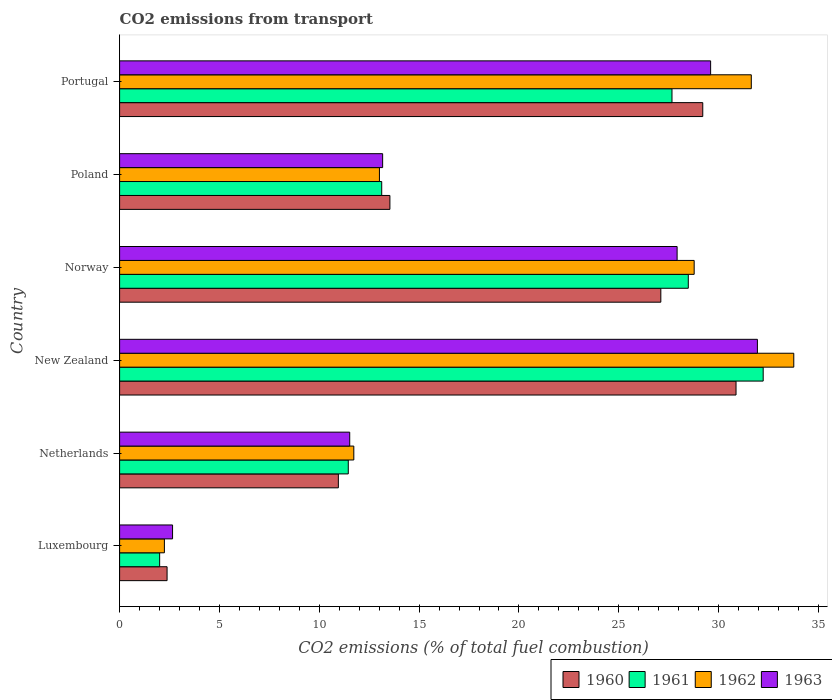How many different coloured bars are there?
Your answer should be compact. 4. Are the number of bars on each tick of the Y-axis equal?
Your answer should be compact. Yes. What is the total CO2 emitted in 1960 in Poland?
Offer a terse response. 13.54. Across all countries, what is the maximum total CO2 emitted in 1961?
Your response must be concise. 32.23. Across all countries, what is the minimum total CO2 emitted in 1961?
Give a very brief answer. 2.01. In which country was the total CO2 emitted in 1960 maximum?
Your response must be concise. New Zealand. In which country was the total CO2 emitted in 1960 minimum?
Make the answer very short. Luxembourg. What is the total total CO2 emitted in 1962 in the graph?
Your response must be concise. 121.17. What is the difference between the total CO2 emitted in 1962 in Netherlands and that in Norway?
Your response must be concise. -17.05. What is the difference between the total CO2 emitted in 1962 in Poland and the total CO2 emitted in 1961 in Luxembourg?
Your answer should be compact. 11.01. What is the average total CO2 emitted in 1960 per country?
Make the answer very short. 19.01. What is the difference between the total CO2 emitted in 1962 and total CO2 emitted in 1961 in Portugal?
Your answer should be very brief. 3.97. In how many countries, is the total CO2 emitted in 1961 greater than 25 ?
Provide a succinct answer. 3. What is the ratio of the total CO2 emitted in 1963 in New Zealand to that in Portugal?
Your answer should be very brief. 1.08. Is the total CO2 emitted in 1962 in New Zealand less than that in Norway?
Give a very brief answer. No. What is the difference between the highest and the second highest total CO2 emitted in 1961?
Keep it short and to the point. 3.75. What is the difference between the highest and the lowest total CO2 emitted in 1962?
Keep it short and to the point. 31.52. Is the sum of the total CO2 emitted in 1960 in Netherlands and Poland greater than the maximum total CO2 emitted in 1961 across all countries?
Provide a short and direct response. No. What does the 1st bar from the top in Poland represents?
Provide a succinct answer. 1963. How many countries are there in the graph?
Provide a succinct answer. 6. What is the difference between two consecutive major ticks on the X-axis?
Give a very brief answer. 5. Are the values on the major ticks of X-axis written in scientific E-notation?
Your answer should be very brief. No. Does the graph contain any zero values?
Provide a short and direct response. No. How many legend labels are there?
Give a very brief answer. 4. What is the title of the graph?
Provide a succinct answer. CO2 emissions from transport. Does "1981" appear as one of the legend labels in the graph?
Offer a very short reply. No. What is the label or title of the X-axis?
Provide a short and direct response. CO2 emissions (% of total fuel combustion). What is the label or title of the Y-axis?
Ensure brevity in your answer.  Country. What is the CO2 emissions (% of total fuel combustion) of 1960 in Luxembourg?
Your answer should be very brief. 2.38. What is the CO2 emissions (% of total fuel combustion) of 1961 in Luxembourg?
Give a very brief answer. 2.01. What is the CO2 emissions (% of total fuel combustion) in 1962 in Luxembourg?
Your answer should be very brief. 2.24. What is the CO2 emissions (% of total fuel combustion) of 1963 in Luxembourg?
Your response must be concise. 2.65. What is the CO2 emissions (% of total fuel combustion) in 1960 in Netherlands?
Keep it short and to the point. 10.96. What is the CO2 emissions (% of total fuel combustion) in 1961 in Netherlands?
Your answer should be compact. 11.45. What is the CO2 emissions (% of total fuel combustion) in 1962 in Netherlands?
Ensure brevity in your answer.  11.73. What is the CO2 emissions (% of total fuel combustion) of 1963 in Netherlands?
Give a very brief answer. 11.53. What is the CO2 emissions (% of total fuel combustion) in 1960 in New Zealand?
Ensure brevity in your answer.  30.87. What is the CO2 emissions (% of total fuel combustion) of 1961 in New Zealand?
Offer a very short reply. 32.23. What is the CO2 emissions (% of total fuel combustion) of 1962 in New Zealand?
Give a very brief answer. 33.77. What is the CO2 emissions (% of total fuel combustion) of 1963 in New Zealand?
Provide a short and direct response. 31.94. What is the CO2 emissions (% of total fuel combustion) of 1960 in Norway?
Your answer should be very brief. 27.11. What is the CO2 emissions (% of total fuel combustion) in 1961 in Norway?
Offer a very short reply. 28.48. What is the CO2 emissions (% of total fuel combustion) of 1962 in Norway?
Offer a very short reply. 28.78. What is the CO2 emissions (% of total fuel combustion) of 1963 in Norway?
Keep it short and to the point. 27.92. What is the CO2 emissions (% of total fuel combustion) in 1960 in Poland?
Provide a succinct answer. 13.54. What is the CO2 emissions (% of total fuel combustion) in 1961 in Poland?
Ensure brevity in your answer.  13.13. What is the CO2 emissions (% of total fuel combustion) of 1962 in Poland?
Provide a short and direct response. 13.01. What is the CO2 emissions (% of total fuel combustion) in 1963 in Poland?
Offer a very short reply. 13.17. What is the CO2 emissions (% of total fuel combustion) of 1960 in Portugal?
Your response must be concise. 29.21. What is the CO2 emissions (% of total fuel combustion) of 1961 in Portugal?
Offer a very short reply. 27.67. What is the CO2 emissions (% of total fuel combustion) in 1962 in Portugal?
Offer a terse response. 31.64. What is the CO2 emissions (% of total fuel combustion) in 1963 in Portugal?
Provide a succinct answer. 29.6. Across all countries, what is the maximum CO2 emissions (% of total fuel combustion) of 1960?
Provide a succinct answer. 30.87. Across all countries, what is the maximum CO2 emissions (% of total fuel combustion) in 1961?
Your answer should be very brief. 32.23. Across all countries, what is the maximum CO2 emissions (% of total fuel combustion) in 1962?
Offer a terse response. 33.77. Across all countries, what is the maximum CO2 emissions (% of total fuel combustion) in 1963?
Provide a succinct answer. 31.94. Across all countries, what is the minimum CO2 emissions (% of total fuel combustion) in 1960?
Keep it short and to the point. 2.38. Across all countries, what is the minimum CO2 emissions (% of total fuel combustion) in 1961?
Make the answer very short. 2.01. Across all countries, what is the minimum CO2 emissions (% of total fuel combustion) in 1962?
Make the answer very short. 2.24. Across all countries, what is the minimum CO2 emissions (% of total fuel combustion) in 1963?
Provide a short and direct response. 2.65. What is the total CO2 emissions (% of total fuel combustion) in 1960 in the graph?
Provide a succinct answer. 114.06. What is the total CO2 emissions (% of total fuel combustion) in 1961 in the graph?
Your response must be concise. 114.97. What is the total CO2 emissions (% of total fuel combustion) in 1962 in the graph?
Provide a short and direct response. 121.17. What is the total CO2 emissions (% of total fuel combustion) of 1963 in the graph?
Your answer should be very brief. 116.82. What is the difference between the CO2 emissions (% of total fuel combustion) of 1960 in Luxembourg and that in Netherlands?
Provide a short and direct response. -8.58. What is the difference between the CO2 emissions (% of total fuel combustion) of 1961 in Luxembourg and that in Netherlands?
Give a very brief answer. -9.45. What is the difference between the CO2 emissions (% of total fuel combustion) of 1962 in Luxembourg and that in Netherlands?
Make the answer very short. -9.49. What is the difference between the CO2 emissions (% of total fuel combustion) in 1963 in Luxembourg and that in Netherlands?
Offer a terse response. -8.87. What is the difference between the CO2 emissions (% of total fuel combustion) in 1960 in Luxembourg and that in New Zealand?
Keep it short and to the point. -28.5. What is the difference between the CO2 emissions (% of total fuel combustion) of 1961 in Luxembourg and that in New Zealand?
Your answer should be compact. -30.23. What is the difference between the CO2 emissions (% of total fuel combustion) in 1962 in Luxembourg and that in New Zealand?
Offer a terse response. -31.52. What is the difference between the CO2 emissions (% of total fuel combustion) of 1963 in Luxembourg and that in New Zealand?
Offer a very short reply. -29.29. What is the difference between the CO2 emissions (% of total fuel combustion) in 1960 in Luxembourg and that in Norway?
Your response must be concise. -24.73. What is the difference between the CO2 emissions (% of total fuel combustion) of 1961 in Luxembourg and that in Norway?
Your answer should be very brief. -26.48. What is the difference between the CO2 emissions (% of total fuel combustion) in 1962 in Luxembourg and that in Norway?
Provide a short and direct response. -26.53. What is the difference between the CO2 emissions (% of total fuel combustion) of 1963 in Luxembourg and that in Norway?
Your response must be concise. -25.27. What is the difference between the CO2 emissions (% of total fuel combustion) in 1960 in Luxembourg and that in Poland?
Keep it short and to the point. -11.16. What is the difference between the CO2 emissions (% of total fuel combustion) in 1961 in Luxembourg and that in Poland?
Provide a succinct answer. -11.12. What is the difference between the CO2 emissions (% of total fuel combustion) in 1962 in Luxembourg and that in Poland?
Keep it short and to the point. -10.77. What is the difference between the CO2 emissions (% of total fuel combustion) of 1963 in Luxembourg and that in Poland?
Make the answer very short. -10.52. What is the difference between the CO2 emissions (% of total fuel combustion) of 1960 in Luxembourg and that in Portugal?
Your response must be concise. -26.83. What is the difference between the CO2 emissions (% of total fuel combustion) in 1961 in Luxembourg and that in Portugal?
Ensure brevity in your answer.  -25.66. What is the difference between the CO2 emissions (% of total fuel combustion) in 1962 in Luxembourg and that in Portugal?
Offer a terse response. -29.4. What is the difference between the CO2 emissions (% of total fuel combustion) of 1963 in Luxembourg and that in Portugal?
Offer a terse response. -26.95. What is the difference between the CO2 emissions (% of total fuel combustion) in 1960 in Netherlands and that in New Zealand?
Give a very brief answer. -19.92. What is the difference between the CO2 emissions (% of total fuel combustion) of 1961 in Netherlands and that in New Zealand?
Your response must be concise. -20.78. What is the difference between the CO2 emissions (% of total fuel combustion) of 1962 in Netherlands and that in New Zealand?
Your answer should be very brief. -22.04. What is the difference between the CO2 emissions (% of total fuel combustion) of 1963 in Netherlands and that in New Zealand?
Your answer should be very brief. -20.42. What is the difference between the CO2 emissions (% of total fuel combustion) of 1960 in Netherlands and that in Norway?
Provide a succinct answer. -16.15. What is the difference between the CO2 emissions (% of total fuel combustion) in 1961 in Netherlands and that in Norway?
Your response must be concise. -17.03. What is the difference between the CO2 emissions (% of total fuel combustion) in 1962 in Netherlands and that in Norway?
Give a very brief answer. -17.05. What is the difference between the CO2 emissions (% of total fuel combustion) in 1963 in Netherlands and that in Norway?
Make the answer very short. -16.4. What is the difference between the CO2 emissions (% of total fuel combustion) of 1960 in Netherlands and that in Poland?
Offer a very short reply. -2.58. What is the difference between the CO2 emissions (% of total fuel combustion) of 1961 in Netherlands and that in Poland?
Offer a very short reply. -1.67. What is the difference between the CO2 emissions (% of total fuel combustion) in 1962 in Netherlands and that in Poland?
Provide a succinct answer. -1.28. What is the difference between the CO2 emissions (% of total fuel combustion) in 1963 in Netherlands and that in Poland?
Give a very brief answer. -1.65. What is the difference between the CO2 emissions (% of total fuel combustion) in 1960 in Netherlands and that in Portugal?
Ensure brevity in your answer.  -18.25. What is the difference between the CO2 emissions (% of total fuel combustion) in 1961 in Netherlands and that in Portugal?
Make the answer very short. -16.21. What is the difference between the CO2 emissions (% of total fuel combustion) in 1962 in Netherlands and that in Portugal?
Provide a succinct answer. -19.91. What is the difference between the CO2 emissions (% of total fuel combustion) in 1963 in Netherlands and that in Portugal?
Ensure brevity in your answer.  -18.08. What is the difference between the CO2 emissions (% of total fuel combustion) in 1960 in New Zealand and that in Norway?
Provide a short and direct response. 3.77. What is the difference between the CO2 emissions (% of total fuel combustion) in 1961 in New Zealand and that in Norway?
Your answer should be compact. 3.75. What is the difference between the CO2 emissions (% of total fuel combustion) of 1962 in New Zealand and that in Norway?
Ensure brevity in your answer.  4.99. What is the difference between the CO2 emissions (% of total fuel combustion) of 1963 in New Zealand and that in Norway?
Provide a short and direct response. 4.02. What is the difference between the CO2 emissions (% of total fuel combustion) in 1960 in New Zealand and that in Poland?
Your answer should be very brief. 17.34. What is the difference between the CO2 emissions (% of total fuel combustion) in 1961 in New Zealand and that in Poland?
Provide a succinct answer. 19.11. What is the difference between the CO2 emissions (% of total fuel combustion) of 1962 in New Zealand and that in Poland?
Give a very brief answer. 20.75. What is the difference between the CO2 emissions (% of total fuel combustion) in 1963 in New Zealand and that in Poland?
Your answer should be compact. 18.77. What is the difference between the CO2 emissions (% of total fuel combustion) in 1960 in New Zealand and that in Portugal?
Keep it short and to the point. 1.67. What is the difference between the CO2 emissions (% of total fuel combustion) of 1961 in New Zealand and that in Portugal?
Provide a succinct answer. 4.57. What is the difference between the CO2 emissions (% of total fuel combustion) in 1962 in New Zealand and that in Portugal?
Keep it short and to the point. 2.13. What is the difference between the CO2 emissions (% of total fuel combustion) of 1963 in New Zealand and that in Portugal?
Your answer should be very brief. 2.34. What is the difference between the CO2 emissions (% of total fuel combustion) in 1960 in Norway and that in Poland?
Make the answer very short. 13.57. What is the difference between the CO2 emissions (% of total fuel combustion) in 1961 in Norway and that in Poland?
Offer a terse response. 15.36. What is the difference between the CO2 emissions (% of total fuel combustion) of 1962 in Norway and that in Poland?
Keep it short and to the point. 15.76. What is the difference between the CO2 emissions (% of total fuel combustion) in 1963 in Norway and that in Poland?
Provide a short and direct response. 14.75. What is the difference between the CO2 emissions (% of total fuel combustion) in 1960 in Norway and that in Portugal?
Make the answer very short. -2.1. What is the difference between the CO2 emissions (% of total fuel combustion) in 1961 in Norway and that in Portugal?
Offer a terse response. 0.82. What is the difference between the CO2 emissions (% of total fuel combustion) of 1962 in Norway and that in Portugal?
Make the answer very short. -2.86. What is the difference between the CO2 emissions (% of total fuel combustion) in 1963 in Norway and that in Portugal?
Your response must be concise. -1.68. What is the difference between the CO2 emissions (% of total fuel combustion) of 1960 in Poland and that in Portugal?
Give a very brief answer. -15.67. What is the difference between the CO2 emissions (% of total fuel combustion) of 1961 in Poland and that in Portugal?
Provide a short and direct response. -14.54. What is the difference between the CO2 emissions (% of total fuel combustion) in 1962 in Poland and that in Portugal?
Make the answer very short. -18.62. What is the difference between the CO2 emissions (% of total fuel combustion) of 1963 in Poland and that in Portugal?
Provide a short and direct response. -16.43. What is the difference between the CO2 emissions (% of total fuel combustion) in 1960 in Luxembourg and the CO2 emissions (% of total fuel combustion) in 1961 in Netherlands?
Ensure brevity in your answer.  -9.08. What is the difference between the CO2 emissions (% of total fuel combustion) in 1960 in Luxembourg and the CO2 emissions (% of total fuel combustion) in 1962 in Netherlands?
Offer a very short reply. -9.35. What is the difference between the CO2 emissions (% of total fuel combustion) in 1960 in Luxembourg and the CO2 emissions (% of total fuel combustion) in 1963 in Netherlands?
Your answer should be compact. -9.15. What is the difference between the CO2 emissions (% of total fuel combustion) of 1961 in Luxembourg and the CO2 emissions (% of total fuel combustion) of 1962 in Netherlands?
Keep it short and to the point. -9.72. What is the difference between the CO2 emissions (% of total fuel combustion) in 1961 in Luxembourg and the CO2 emissions (% of total fuel combustion) in 1963 in Netherlands?
Give a very brief answer. -9.52. What is the difference between the CO2 emissions (% of total fuel combustion) in 1962 in Luxembourg and the CO2 emissions (% of total fuel combustion) in 1963 in Netherlands?
Your response must be concise. -9.28. What is the difference between the CO2 emissions (% of total fuel combustion) in 1960 in Luxembourg and the CO2 emissions (% of total fuel combustion) in 1961 in New Zealand?
Provide a short and direct response. -29.86. What is the difference between the CO2 emissions (% of total fuel combustion) of 1960 in Luxembourg and the CO2 emissions (% of total fuel combustion) of 1962 in New Zealand?
Make the answer very short. -31.39. What is the difference between the CO2 emissions (% of total fuel combustion) of 1960 in Luxembourg and the CO2 emissions (% of total fuel combustion) of 1963 in New Zealand?
Offer a very short reply. -29.57. What is the difference between the CO2 emissions (% of total fuel combustion) in 1961 in Luxembourg and the CO2 emissions (% of total fuel combustion) in 1962 in New Zealand?
Offer a very short reply. -31.76. What is the difference between the CO2 emissions (% of total fuel combustion) of 1961 in Luxembourg and the CO2 emissions (% of total fuel combustion) of 1963 in New Zealand?
Your answer should be compact. -29.94. What is the difference between the CO2 emissions (% of total fuel combustion) of 1962 in Luxembourg and the CO2 emissions (% of total fuel combustion) of 1963 in New Zealand?
Provide a succinct answer. -29.7. What is the difference between the CO2 emissions (% of total fuel combustion) in 1960 in Luxembourg and the CO2 emissions (% of total fuel combustion) in 1961 in Norway?
Make the answer very short. -26.1. What is the difference between the CO2 emissions (% of total fuel combustion) in 1960 in Luxembourg and the CO2 emissions (% of total fuel combustion) in 1962 in Norway?
Make the answer very short. -26.4. What is the difference between the CO2 emissions (% of total fuel combustion) of 1960 in Luxembourg and the CO2 emissions (% of total fuel combustion) of 1963 in Norway?
Ensure brevity in your answer.  -25.54. What is the difference between the CO2 emissions (% of total fuel combustion) of 1961 in Luxembourg and the CO2 emissions (% of total fuel combustion) of 1962 in Norway?
Your response must be concise. -26.77. What is the difference between the CO2 emissions (% of total fuel combustion) in 1961 in Luxembourg and the CO2 emissions (% of total fuel combustion) in 1963 in Norway?
Keep it short and to the point. -25.92. What is the difference between the CO2 emissions (% of total fuel combustion) in 1962 in Luxembourg and the CO2 emissions (% of total fuel combustion) in 1963 in Norway?
Make the answer very short. -25.68. What is the difference between the CO2 emissions (% of total fuel combustion) in 1960 in Luxembourg and the CO2 emissions (% of total fuel combustion) in 1961 in Poland?
Offer a terse response. -10.75. What is the difference between the CO2 emissions (% of total fuel combustion) of 1960 in Luxembourg and the CO2 emissions (% of total fuel combustion) of 1962 in Poland?
Keep it short and to the point. -10.64. What is the difference between the CO2 emissions (% of total fuel combustion) of 1960 in Luxembourg and the CO2 emissions (% of total fuel combustion) of 1963 in Poland?
Your response must be concise. -10.8. What is the difference between the CO2 emissions (% of total fuel combustion) in 1961 in Luxembourg and the CO2 emissions (% of total fuel combustion) in 1962 in Poland?
Your answer should be very brief. -11.01. What is the difference between the CO2 emissions (% of total fuel combustion) of 1961 in Luxembourg and the CO2 emissions (% of total fuel combustion) of 1963 in Poland?
Offer a terse response. -11.17. What is the difference between the CO2 emissions (% of total fuel combustion) of 1962 in Luxembourg and the CO2 emissions (% of total fuel combustion) of 1963 in Poland?
Provide a succinct answer. -10.93. What is the difference between the CO2 emissions (% of total fuel combustion) of 1960 in Luxembourg and the CO2 emissions (% of total fuel combustion) of 1961 in Portugal?
Offer a terse response. -25.29. What is the difference between the CO2 emissions (% of total fuel combustion) of 1960 in Luxembourg and the CO2 emissions (% of total fuel combustion) of 1962 in Portugal?
Your response must be concise. -29.26. What is the difference between the CO2 emissions (% of total fuel combustion) in 1960 in Luxembourg and the CO2 emissions (% of total fuel combustion) in 1963 in Portugal?
Your answer should be very brief. -27.22. What is the difference between the CO2 emissions (% of total fuel combustion) of 1961 in Luxembourg and the CO2 emissions (% of total fuel combustion) of 1962 in Portugal?
Make the answer very short. -29.63. What is the difference between the CO2 emissions (% of total fuel combustion) of 1961 in Luxembourg and the CO2 emissions (% of total fuel combustion) of 1963 in Portugal?
Keep it short and to the point. -27.6. What is the difference between the CO2 emissions (% of total fuel combustion) of 1962 in Luxembourg and the CO2 emissions (% of total fuel combustion) of 1963 in Portugal?
Provide a short and direct response. -27.36. What is the difference between the CO2 emissions (% of total fuel combustion) in 1960 in Netherlands and the CO2 emissions (% of total fuel combustion) in 1961 in New Zealand?
Ensure brevity in your answer.  -21.28. What is the difference between the CO2 emissions (% of total fuel combustion) in 1960 in Netherlands and the CO2 emissions (% of total fuel combustion) in 1962 in New Zealand?
Provide a short and direct response. -22.81. What is the difference between the CO2 emissions (% of total fuel combustion) of 1960 in Netherlands and the CO2 emissions (% of total fuel combustion) of 1963 in New Zealand?
Provide a short and direct response. -20.99. What is the difference between the CO2 emissions (% of total fuel combustion) in 1961 in Netherlands and the CO2 emissions (% of total fuel combustion) in 1962 in New Zealand?
Provide a short and direct response. -22.31. What is the difference between the CO2 emissions (% of total fuel combustion) in 1961 in Netherlands and the CO2 emissions (% of total fuel combustion) in 1963 in New Zealand?
Make the answer very short. -20.49. What is the difference between the CO2 emissions (% of total fuel combustion) of 1962 in Netherlands and the CO2 emissions (% of total fuel combustion) of 1963 in New Zealand?
Your response must be concise. -20.21. What is the difference between the CO2 emissions (% of total fuel combustion) in 1960 in Netherlands and the CO2 emissions (% of total fuel combustion) in 1961 in Norway?
Provide a short and direct response. -17.53. What is the difference between the CO2 emissions (% of total fuel combustion) of 1960 in Netherlands and the CO2 emissions (% of total fuel combustion) of 1962 in Norway?
Ensure brevity in your answer.  -17.82. What is the difference between the CO2 emissions (% of total fuel combustion) in 1960 in Netherlands and the CO2 emissions (% of total fuel combustion) in 1963 in Norway?
Your answer should be very brief. -16.97. What is the difference between the CO2 emissions (% of total fuel combustion) in 1961 in Netherlands and the CO2 emissions (% of total fuel combustion) in 1962 in Norway?
Your answer should be compact. -17.32. What is the difference between the CO2 emissions (% of total fuel combustion) in 1961 in Netherlands and the CO2 emissions (% of total fuel combustion) in 1963 in Norway?
Make the answer very short. -16.47. What is the difference between the CO2 emissions (% of total fuel combustion) of 1962 in Netherlands and the CO2 emissions (% of total fuel combustion) of 1963 in Norway?
Offer a very short reply. -16.19. What is the difference between the CO2 emissions (% of total fuel combustion) of 1960 in Netherlands and the CO2 emissions (% of total fuel combustion) of 1961 in Poland?
Your answer should be compact. -2.17. What is the difference between the CO2 emissions (% of total fuel combustion) in 1960 in Netherlands and the CO2 emissions (% of total fuel combustion) in 1962 in Poland?
Give a very brief answer. -2.06. What is the difference between the CO2 emissions (% of total fuel combustion) in 1960 in Netherlands and the CO2 emissions (% of total fuel combustion) in 1963 in Poland?
Make the answer very short. -2.22. What is the difference between the CO2 emissions (% of total fuel combustion) in 1961 in Netherlands and the CO2 emissions (% of total fuel combustion) in 1962 in Poland?
Your response must be concise. -1.56. What is the difference between the CO2 emissions (% of total fuel combustion) in 1961 in Netherlands and the CO2 emissions (% of total fuel combustion) in 1963 in Poland?
Provide a succinct answer. -1.72. What is the difference between the CO2 emissions (% of total fuel combustion) in 1962 in Netherlands and the CO2 emissions (% of total fuel combustion) in 1963 in Poland?
Give a very brief answer. -1.44. What is the difference between the CO2 emissions (% of total fuel combustion) in 1960 in Netherlands and the CO2 emissions (% of total fuel combustion) in 1961 in Portugal?
Ensure brevity in your answer.  -16.71. What is the difference between the CO2 emissions (% of total fuel combustion) in 1960 in Netherlands and the CO2 emissions (% of total fuel combustion) in 1962 in Portugal?
Your answer should be very brief. -20.68. What is the difference between the CO2 emissions (% of total fuel combustion) in 1960 in Netherlands and the CO2 emissions (% of total fuel combustion) in 1963 in Portugal?
Your answer should be very brief. -18.64. What is the difference between the CO2 emissions (% of total fuel combustion) of 1961 in Netherlands and the CO2 emissions (% of total fuel combustion) of 1962 in Portugal?
Your answer should be very brief. -20.18. What is the difference between the CO2 emissions (% of total fuel combustion) of 1961 in Netherlands and the CO2 emissions (% of total fuel combustion) of 1963 in Portugal?
Provide a short and direct response. -18.15. What is the difference between the CO2 emissions (% of total fuel combustion) of 1962 in Netherlands and the CO2 emissions (% of total fuel combustion) of 1963 in Portugal?
Keep it short and to the point. -17.87. What is the difference between the CO2 emissions (% of total fuel combustion) in 1960 in New Zealand and the CO2 emissions (% of total fuel combustion) in 1961 in Norway?
Provide a short and direct response. 2.39. What is the difference between the CO2 emissions (% of total fuel combustion) in 1960 in New Zealand and the CO2 emissions (% of total fuel combustion) in 1962 in Norway?
Offer a terse response. 2.1. What is the difference between the CO2 emissions (% of total fuel combustion) in 1960 in New Zealand and the CO2 emissions (% of total fuel combustion) in 1963 in Norway?
Make the answer very short. 2.95. What is the difference between the CO2 emissions (% of total fuel combustion) in 1961 in New Zealand and the CO2 emissions (% of total fuel combustion) in 1962 in Norway?
Ensure brevity in your answer.  3.46. What is the difference between the CO2 emissions (% of total fuel combustion) in 1961 in New Zealand and the CO2 emissions (% of total fuel combustion) in 1963 in Norway?
Make the answer very short. 4.31. What is the difference between the CO2 emissions (% of total fuel combustion) in 1962 in New Zealand and the CO2 emissions (% of total fuel combustion) in 1963 in Norway?
Your answer should be very brief. 5.84. What is the difference between the CO2 emissions (% of total fuel combustion) in 1960 in New Zealand and the CO2 emissions (% of total fuel combustion) in 1961 in Poland?
Keep it short and to the point. 17.75. What is the difference between the CO2 emissions (% of total fuel combustion) in 1960 in New Zealand and the CO2 emissions (% of total fuel combustion) in 1962 in Poland?
Your answer should be compact. 17.86. What is the difference between the CO2 emissions (% of total fuel combustion) of 1960 in New Zealand and the CO2 emissions (% of total fuel combustion) of 1963 in Poland?
Make the answer very short. 17.7. What is the difference between the CO2 emissions (% of total fuel combustion) in 1961 in New Zealand and the CO2 emissions (% of total fuel combustion) in 1962 in Poland?
Your answer should be compact. 19.22. What is the difference between the CO2 emissions (% of total fuel combustion) in 1961 in New Zealand and the CO2 emissions (% of total fuel combustion) in 1963 in Poland?
Your answer should be compact. 19.06. What is the difference between the CO2 emissions (% of total fuel combustion) in 1962 in New Zealand and the CO2 emissions (% of total fuel combustion) in 1963 in Poland?
Provide a succinct answer. 20.59. What is the difference between the CO2 emissions (% of total fuel combustion) in 1960 in New Zealand and the CO2 emissions (% of total fuel combustion) in 1961 in Portugal?
Provide a succinct answer. 3.21. What is the difference between the CO2 emissions (% of total fuel combustion) in 1960 in New Zealand and the CO2 emissions (% of total fuel combustion) in 1962 in Portugal?
Offer a very short reply. -0.76. What is the difference between the CO2 emissions (% of total fuel combustion) of 1960 in New Zealand and the CO2 emissions (% of total fuel combustion) of 1963 in Portugal?
Give a very brief answer. 1.27. What is the difference between the CO2 emissions (% of total fuel combustion) of 1961 in New Zealand and the CO2 emissions (% of total fuel combustion) of 1962 in Portugal?
Provide a short and direct response. 0.6. What is the difference between the CO2 emissions (% of total fuel combustion) of 1961 in New Zealand and the CO2 emissions (% of total fuel combustion) of 1963 in Portugal?
Keep it short and to the point. 2.63. What is the difference between the CO2 emissions (% of total fuel combustion) of 1962 in New Zealand and the CO2 emissions (% of total fuel combustion) of 1963 in Portugal?
Give a very brief answer. 4.17. What is the difference between the CO2 emissions (% of total fuel combustion) in 1960 in Norway and the CO2 emissions (% of total fuel combustion) in 1961 in Poland?
Your answer should be compact. 13.98. What is the difference between the CO2 emissions (% of total fuel combustion) of 1960 in Norway and the CO2 emissions (% of total fuel combustion) of 1962 in Poland?
Provide a succinct answer. 14.09. What is the difference between the CO2 emissions (% of total fuel combustion) of 1960 in Norway and the CO2 emissions (% of total fuel combustion) of 1963 in Poland?
Give a very brief answer. 13.93. What is the difference between the CO2 emissions (% of total fuel combustion) in 1961 in Norway and the CO2 emissions (% of total fuel combustion) in 1962 in Poland?
Offer a terse response. 15.47. What is the difference between the CO2 emissions (% of total fuel combustion) of 1961 in Norway and the CO2 emissions (% of total fuel combustion) of 1963 in Poland?
Your response must be concise. 15.31. What is the difference between the CO2 emissions (% of total fuel combustion) of 1962 in Norway and the CO2 emissions (% of total fuel combustion) of 1963 in Poland?
Your response must be concise. 15.6. What is the difference between the CO2 emissions (% of total fuel combustion) in 1960 in Norway and the CO2 emissions (% of total fuel combustion) in 1961 in Portugal?
Give a very brief answer. -0.56. What is the difference between the CO2 emissions (% of total fuel combustion) in 1960 in Norway and the CO2 emissions (% of total fuel combustion) in 1962 in Portugal?
Your answer should be compact. -4.53. What is the difference between the CO2 emissions (% of total fuel combustion) of 1960 in Norway and the CO2 emissions (% of total fuel combustion) of 1963 in Portugal?
Offer a very short reply. -2.49. What is the difference between the CO2 emissions (% of total fuel combustion) in 1961 in Norway and the CO2 emissions (% of total fuel combustion) in 1962 in Portugal?
Give a very brief answer. -3.16. What is the difference between the CO2 emissions (% of total fuel combustion) of 1961 in Norway and the CO2 emissions (% of total fuel combustion) of 1963 in Portugal?
Provide a short and direct response. -1.12. What is the difference between the CO2 emissions (% of total fuel combustion) in 1962 in Norway and the CO2 emissions (% of total fuel combustion) in 1963 in Portugal?
Offer a very short reply. -0.82. What is the difference between the CO2 emissions (% of total fuel combustion) in 1960 in Poland and the CO2 emissions (% of total fuel combustion) in 1961 in Portugal?
Provide a short and direct response. -14.13. What is the difference between the CO2 emissions (% of total fuel combustion) of 1960 in Poland and the CO2 emissions (% of total fuel combustion) of 1962 in Portugal?
Your answer should be compact. -18.1. What is the difference between the CO2 emissions (% of total fuel combustion) in 1960 in Poland and the CO2 emissions (% of total fuel combustion) in 1963 in Portugal?
Offer a terse response. -16.06. What is the difference between the CO2 emissions (% of total fuel combustion) in 1961 in Poland and the CO2 emissions (% of total fuel combustion) in 1962 in Portugal?
Offer a terse response. -18.51. What is the difference between the CO2 emissions (% of total fuel combustion) of 1961 in Poland and the CO2 emissions (% of total fuel combustion) of 1963 in Portugal?
Offer a terse response. -16.47. What is the difference between the CO2 emissions (% of total fuel combustion) of 1962 in Poland and the CO2 emissions (% of total fuel combustion) of 1963 in Portugal?
Keep it short and to the point. -16.59. What is the average CO2 emissions (% of total fuel combustion) of 1960 per country?
Your response must be concise. 19.01. What is the average CO2 emissions (% of total fuel combustion) of 1961 per country?
Provide a succinct answer. 19.16. What is the average CO2 emissions (% of total fuel combustion) of 1962 per country?
Give a very brief answer. 20.2. What is the average CO2 emissions (% of total fuel combustion) in 1963 per country?
Ensure brevity in your answer.  19.47. What is the difference between the CO2 emissions (% of total fuel combustion) in 1960 and CO2 emissions (% of total fuel combustion) in 1961 in Luxembourg?
Offer a very short reply. 0.37. What is the difference between the CO2 emissions (% of total fuel combustion) in 1960 and CO2 emissions (% of total fuel combustion) in 1962 in Luxembourg?
Offer a terse response. 0.14. What is the difference between the CO2 emissions (% of total fuel combustion) of 1960 and CO2 emissions (% of total fuel combustion) of 1963 in Luxembourg?
Ensure brevity in your answer.  -0.27. What is the difference between the CO2 emissions (% of total fuel combustion) in 1961 and CO2 emissions (% of total fuel combustion) in 1962 in Luxembourg?
Offer a very short reply. -0.24. What is the difference between the CO2 emissions (% of total fuel combustion) in 1961 and CO2 emissions (% of total fuel combustion) in 1963 in Luxembourg?
Ensure brevity in your answer.  -0.65. What is the difference between the CO2 emissions (% of total fuel combustion) in 1962 and CO2 emissions (% of total fuel combustion) in 1963 in Luxembourg?
Keep it short and to the point. -0.41. What is the difference between the CO2 emissions (% of total fuel combustion) of 1960 and CO2 emissions (% of total fuel combustion) of 1961 in Netherlands?
Provide a succinct answer. -0.5. What is the difference between the CO2 emissions (% of total fuel combustion) of 1960 and CO2 emissions (% of total fuel combustion) of 1962 in Netherlands?
Offer a very short reply. -0.77. What is the difference between the CO2 emissions (% of total fuel combustion) of 1960 and CO2 emissions (% of total fuel combustion) of 1963 in Netherlands?
Make the answer very short. -0.57. What is the difference between the CO2 emissions (% of total fuel combustion) of 1961 and CO2 emissions (% of total fuel combustion) of 1962 in Netherlands?
Offer a very short reply. -0.28. What is the difference between the CO2 emissions (% of total fuel combustion) of 1961 and CO2 emissions (% of total fuel combustion) of 1963 in Netherlands?
Provide a short and direct response. -0.07. What is the difference between the CO2 emissions (% of total fuel combustion) in 1962 and CO2 emissions (% of total fuel combustion) in 1963 in Netherlands?
Your response must be concise. 0.21. What is the difference between the CO2 emissions (% of total fuel combustion) of 1960 and CO2 emissions (% of total fuel combustion) of 1961 in New Zealand?
Offer a very short reply. -1.36. What is the difference between the CO2 emissions (% of total fuel combustion) in 1960 and CO2 emissions (% of total fuel combustion) in 1962 in New Zealand?
Provide a short and direct response. -2.89. What is the difference between the CO2 emissions (% of total fuel combustion) in 1960 and CO2 emissions (% of total fuel combustion) in 1963 in New Zealand?
Offer a very short reply. -1.07. What is the difference between the CO2 emissions (% of total fuel combustion) of 1961 and CO2 emissions (% of total fuel combustion) of 1962 in New Zealand?
Offer a terse response. -1.53. What is the difference between the CO2 emissions (% of total fuel combustion) in 1961 and CO2 emissions (% of total fuel combustion) in 1963 in New Zealand?
Your response must be concise. 0.29. What is the difference between the CO2 emissions (% of total fuel combustion) of 1962 and CO2 emissions (% of total fuel combustion) of 1963 in New Zealand?
Provide a short and direct response. 1.82. What is the difference between the CO2 emissions (% of total fuel combustion) in 1960 and CO2 emissions (% of total fuel combustion) in 1961 in Norway?
Offer a very short reply. -1.38. What is the difference between the CO2 emissions (% of total fuel combustion) in 1960 and CO2 emissions (% of total fuel combustion) in 1962 in Norway?
Provide a short and direct response. -1.67. What is the difference between the CO2 emissions (% of total fuel combustion) of 1960 and CO2 emissions (% of total fuel combustion) of 1963 in Norway?
Offer a terse response. -0.82. What is the difference between the CO2 emissions (% of total fuel combustion) in 1961 and CO2 emissions (% of total fuel combustion) in 1962 in Norway?
Offer a very short reply. -0.29. What is the difference between the CO2 emissions (% of total fuel combustion) in 1961 and CO2 emissions (% of total fuel combustion) in 1963 in Norway?
Give a very brief answer. 0.56. What is the difference between the CO2 emissions (% of total fuel combustion) of 1962 and CO2 emissions (% of total fuel combustion) of 1963 in Norway?
Offer a terse response. 0.85. What is the difference between the CO2 emissions (% of total fuel combustion) in 1960 and CO2 emissions (% of total fuel combustion) in 1961 in Poland?
Make the answer very short. 0.41. What is the difference between the CO2 emissions (% of total fuel combustion) in 1960 and CO2 emissions (% of total fuel combustion) in 1962 in Poland?
Offer a terse response. 0.52. What is the difference between the CO2 emissions (% of total fuel combustion) of 1960 and CO2 emissions (% of total fuel combustion) of 1963 in Poland?
Give a very brief answer. 0.36. What is the difference between the CO2 emissions (% of total fuel combustion) in 1961 and CO2 emissions (% of total fuel combustion) in 1962 in Poland?
Ensure brevity in your answer.  0.11. What is the difference between the CO2 emissions (% of total fuel combustion) in 1961 and CO2 emissions (% of total fuel combustion) in 1963 in Poland?
Keep it short and to the point. -0.05. What is the difference between the CO2 emissions (% of total fuel combustion) of 1962 and CO2 emissions (% of total fuel combustion) of 1963 in Poland?
Ensure brevity in your answer.  -0.16. What is the difference between the CO2 emissions (% of total fuel combustion) in 1960 and CO2 emissions (% of total fuel combustion) in 1961 in Portugal?
Ensure brevity in your answer.  1.54. What is the difference between the CO2 emissions (% of total fuel combustion) in 1960 and CO2 emissions (% of total fuel combustion) in 1962 in Portugal?
Make the answer very short. -2.43. What is the difference between the CO2 emissions (% of total fuel combustion) of 1960 and CO2 emissions (% of total fuel combustion) of 1963 in Portugal?
Ensure brevity in your answer.  -0.39. What is the difference between the CO2 emissions (% of total fuel combustion) of 1961 and CO2 emissions (% of total fuel combustion) of 1962 in Portugal?
Offer a very short reply. -3.97. What is the difference between the CO2 emissions (% of total fuel combustion) in 1961 and CO2 emissions (% of total fuel combustion) in 1963 in Portugal?
Offer a very short reply. -1.94. What is the difference between the CO2 emissions (% of total fuel combustion) in 1962 and CO2 emissions (% of total fuel combustion) in 1963 in Portugal?
Your response must be concise. 2.04. What is the ratio of the CO2 emissions (% of total fuel combustion) in 1960 in Luxembourg to that in Netherlands?
Keep it short and to the point. 0.22. What is the ratio of the CO2 emissions (% of total fuel combustion) of 1961 in Luxembourg to that in Netherlands?
Ensure brevity in your answer.  0.18. What is the ratio of the CO2 emissions (% of total fuel combustion) in 1962 in Luxembourg to that in Netherlands?
Provide a succinct answer. 0.19. What is the ratio of the CO2 emissions (% of total fuel combustion) in 1963 in Luxembourg to that in Netherlands?
Make the answer very short. 0.23. What is the ratio of the CO2 emissions (% of total fuel combustion) in 1960 in Luxembourg to that in New Zealand?
Your answer should be compact. 0.08. What is the ratio of the CO2 emissions (% of total fuel combustion) of 1961 in Luxembourg to that in New Zealand?
Give a very brief answer. 0.06. What is the ratio of the CO2 emissions (% of total fuel combustion) of 1962 in Luxembourg to that in New Zealand?
Provide a succinct answer. 0.07. What is the ratio of the CO2 emissions (% of total fuel combustion) of 1963 in Luxembourg to that in New Zealand?
Provide a short and direct response. 0.08. What is the ratio of the CO2 emissions (% of total fuel combustion) of 1960 in Luxembourg to that in Norway?
Give a very brief answer. 0.09. What is the ratio of the CO2 emissions (% of total fuel combustion) in 1961 in Luxembourg to that in Norway?
Offer a very short reply. 0.07. What is the ratio of the CO2 emissions (% of total fuel combustion) of 1962 in Luxembourg to that in Norway?
Provide a short and direct response. 0.08. What is the ratio of the CO2 emissions (% of total fuel combustion) of 1963 in Luxembourg to that in Norway?
Keep it short and to the point. 0.1. What is the ratio of the CO2 emissions (% of total fuel combustion) in 1960 in Luxembourg to that in Poland?
Offer a terse response. 0.18. What is the ratio of the CO2 emissions (% of total fuel combustion) in 1961 in Luxembourg to that in Poland?
Give a very brief answer. 0.15. What is the ratio of the CO2 emissions (% of total fuel combustion) in 1962 in Luxembourg to that in Poland?
Provide a succinct answer. 0.17. What is the ratio of the CO2 emissions (% of total fuel combustion) of 1963 in Luxembourg to that in Poland?
Your answer should be very brief. 0.2. What is the ratio of the CO2 emissions (% of total fuel combustion) in 1960 in Luxembourg to that in Portugal?
Offer a terse response. 0.08. What is the ratio of the CO2 emissions (% of total fuel combustion) of 1961 in Luxembourg to that in Portugal?
Your answer should be compact. 0.07. What is the ratio of the CO2 emissions (% of total fuel combustion) of 1962 in Luxembourg to that in Portugal?
Keep it short and to the point. 0.07. What is the ratio of the CO2 emissions (% of total fuel combustion) in 1963 in Luxembourg to that in Portugal?
Offer a terse response. 0.09. What is the ratio of the CO2 emissions (% of total fuel combustion) of 1960 in Netherlands to that in New Zealand?
Keep it short and to the point. 0.35. What is the ratio of the CO2 emissions (% of total fuel combustion) of 1961 in Netherlands to that in New Zealand?
Your response must be concise. 0.36. What is the ratio of the CO2 emissions (% of total fuel combustion) in 1962 in Netherlands to that in New Zealand?
Your response must be concise. 0.35. What is the ratio of the CO2 emissions (% of total fuel combustion) in 1963 in Netherlands to that in New Zealand?
Ensure brevity in your answer.  0.36. What is the ratio of the CO2 emissions (% of total fuel combustion) in 1960 in Netherlands to that in Norway?
Ensure brevity in your answer.  0.4. What is the ratio of the CO2 emissions (% of total fuel combustion) of 1961 in Netherlands to that in Norway?
Give a very brief answer. 0.4. What is the ratio of the CO2 emissions (% of total fuel combustion) of 1962 in Netherlands to that in Norway?
Ensure brevity in your answer.  0.41. What is the ratio of the CO2 emissions (% of total fuel combustion) of 1963 in Netherlands to that in Norway?
Give a very brief answer. 0.41. What is the ratio of the CO2 emissions (% of total fuel combustion) in 1960 in Netherlands to that in Poland?
Offer a terse response. 0.81. What is the ratio of the CO2 emissions (% of total fuel combustion) of 1961 in Netherlands to that in Poland?
Provide a succinct answer. 0.87. What is the ratio of the CO2 emissions (% of total fuel combustion) in 1962 in Netherlands to that in Poland?
Make the answer very short. 0.9. What is the ratio of the CO2 emissions (% of total fuel combustion) of 1963 in Netherlands to that in Poland?
Ensure brevity in your answer.  0.87. What is the ratio of the CO2 emissions (% of total fuel combustion) in 1960 in Netherlands to that in Portugal?
Your answer should be very brief. 0.38. What is the ratio of the CO2 emissions (% of total fuel combustion) of 1961 in Netherlands to that in Portugal?
Provide a succinct answer. 0.41. What is the ratio of the CO2 emissions (% of total fuel combustion) of 1962 in Netherlands to that in Portugal?
Ensure brevity in your answer.  0.37. What is the ratio of the CO2 emissions (% of total fuel combustion) of 1963 in Netherlands to that in Portugal?
Your response must be concise. 0.39. What is the ratio of the CO2 emissions (% of total fuel combustion) in 1960 in New Zealand to that in Norway?
Provide a short and direct response. 1.14. What is the ratio of the CO2 emissions (% of total fuel combustion) of 1961 in New Zealand to that in Norway?
Make the answer very short. 1.13. What is the ratio of the CO2 emissions (% of total fuel combustion) of 1962 in New Zealand to that in Norway?
Keep it short and to the point. 1.17. What is the ratio of the CO2 emissions (% of total fuel combustion) of 1963 in New Zealand to that in Norway?
Your answer should be very brief. 1.14. What is the ratio of the CO2 emissions (% of total fuel combustion) of 1960 in New Zealand to that in Poland?
Make the answer very short. 2.28. What is the ratio of the CO2 emissions (% of total fuel combustion) in 1961 in New Zealand to that in Poland?
Offer a very short reply. 2.46. What is the ratio of the CO2 emissions (% of total fuel combustion) of 1962 in New Zealand to that in Poland?
Provide a short and direct response. 2.59. What is the ratio of the CO2 emissions (% of total fuel combustion) in 1963 in New Zealand to that in Poland?
Your answer should be very brief. 2.42. What is the ratio of the CO2 emissions (% of total fuel combustion) in 1960 in New Zealand to that in Portugal?
Your answer should be very brief. 1.06. What is the ratio of the CO2 emissions (% of total fuel combustion) of 1961 in New Zealand to that in Portugal?
Offer a very short reply. 1.17. What is the ratio of the CO2 emissions (% of total fuel combustion) of 1962 in New Zealand to that in Portugal?
Make the answer very short. 1.07. What is the ratio of the CO2 emissions (% of total fuel combustion) of 1963 in New Zealand to that in Portugal?
Provide a succinct answer. 1.08. What is the ratio of the CO2 emissions (% of total fuel combustion) in 1960 in Norway to that in Poland?
Your response must be concise. 2. What is the ratio of the CO2 emissions (% of total fuel combustion) in 1961 in Norway to that in Poland?
Give a very brief answer. 2.17. What is the ratio of the CO2 emissions (% of total fuel combustion) of 1962 in Norway to that in Poland?
Offer a terse response. 2.21. What is the ratio of the CO2 emissions (% of total fuel combustion) in 1963 in Norway to that in Poland?
Offer a very short reply. 2.12. What is the ratio of the CO2 emissions (% of total fuel combustion) in 1960 in Norway to that in Portugal?
Your answer should be very brief. 0.93. What is the ratio of the CO2 emissions (% of total fuel combustion) of 1961 in Norway to that in Portugal?
Your response must be concise. 1.03. What is the ratio of the CO2 emissions (% of total fuel combustion) of 1962 in Norway to that in Portugal?
Keep it short and to the point. 0.91. What is the ratio of the CO2 emissions (% of total fuel combustion) in 1963 in Norway to that in Portugal?
Provide a short and direct response. 0.94. What is the ratio of the CO2 emissions (% of total fuel combustion) in 1960 in Poland to that in Portugal?
Ensure brevity in your answer.  0.46. What is the ratio of the CO2 emissions (% of total fuel combustion) in 1961 in Poland to that in Portugal?
Give a very brief answer. 0.47. What is the ratio of the CO2 emissions (% of total fuel combustion) of 1962 in Poland to that in Portugal?
Your answer should be compact. 0.41. What is the ratio of the CO2 emissions (% of total fuel combustion) of 1963 in Poland to that in Portugal?
Ensure brevity in your answer.  0.45. What is the difference between the highest and the second highest CO2 emissions (% of total fuel combustion) in 1960?
Offer a terse response. 1.67. What is the difference between the highest and the second highest CO2 emissions (% of total fuel combustion) of 1961?
Keep it short and to the point. 3.75. What is the difference between the highest and the second highest CO2 emissions (% of total fuel combustion) of 1962?
Your answer should be compact. 2.13. What is the difference between the highest and the second highest CO2 emissions (% of total fuel combustion) of 1963?
Keep it short and to the point. 2.34. What is the difference between the highest and the lowest CO2 emissions (% of total fuel combustion) in 1960?
Provide a succinct answer. 28.5. What is the difference between the highest and the lowest CO2 emissions (% of total fuel combustion) in 1961?
Make the answer very short. 30.23. What is the difference between the highest and the lowest CO2 emissions (% of total fuel combustion) in 1962?
Offer a very short reply. 31.52. What is the difference between the highest and the lowest CO2 emissions (% of total fuel combustion) of 1963?
Give a very brief answer. 29.29. 